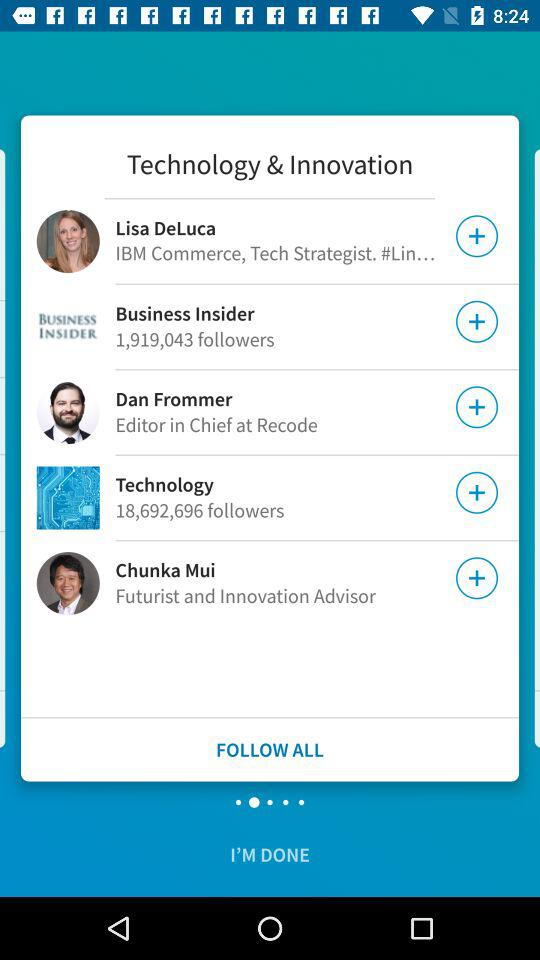What is the name of the futurist and innovation advisor? The name of the futurist and innovation advisor is Chunka Mui. 